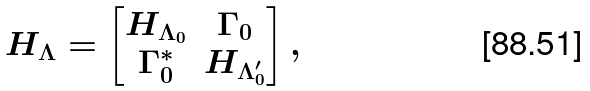Convert formula to latex. <formula><loc_0><loc_0><loc_500><loc_500>H _ { \Lambda } = \begin{bmatrix} H _ { \Lambda _ { 0 } } & \Gamma _ { 0 } \\ \Gamma _ { 0 } ^ { * } & H _ { \Lambda _ { 0 } ^ { \prime } } \end{bmatrix} ,</formula> 